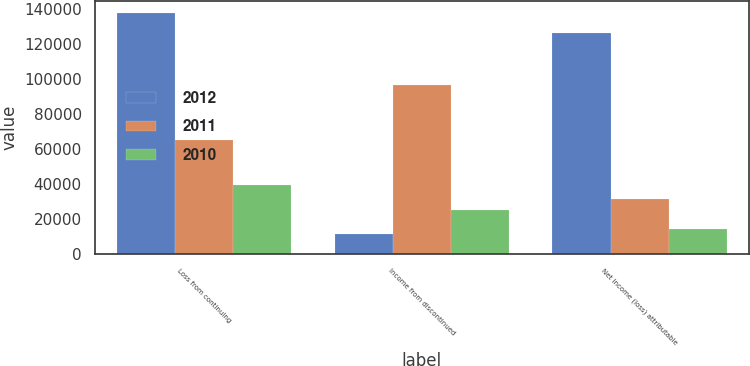Convert chart to OTSL. <chart><loc_0><loc_0><loc_500><loc_500><stacked_bar_chart><ecel><fcel>Loss from continuing<fcel>Income from discontinued<fcel>Net income (loss) attributable<nl><fcel>2012<fcel>137852<fcel>11707<fcel>126145<nl><fcel>2011<fcel>65064<fcel>96480<fcel>31416<nl><fcel>2010<fcel>39448<fcel>25340<fcel>14108<nl></chart> 